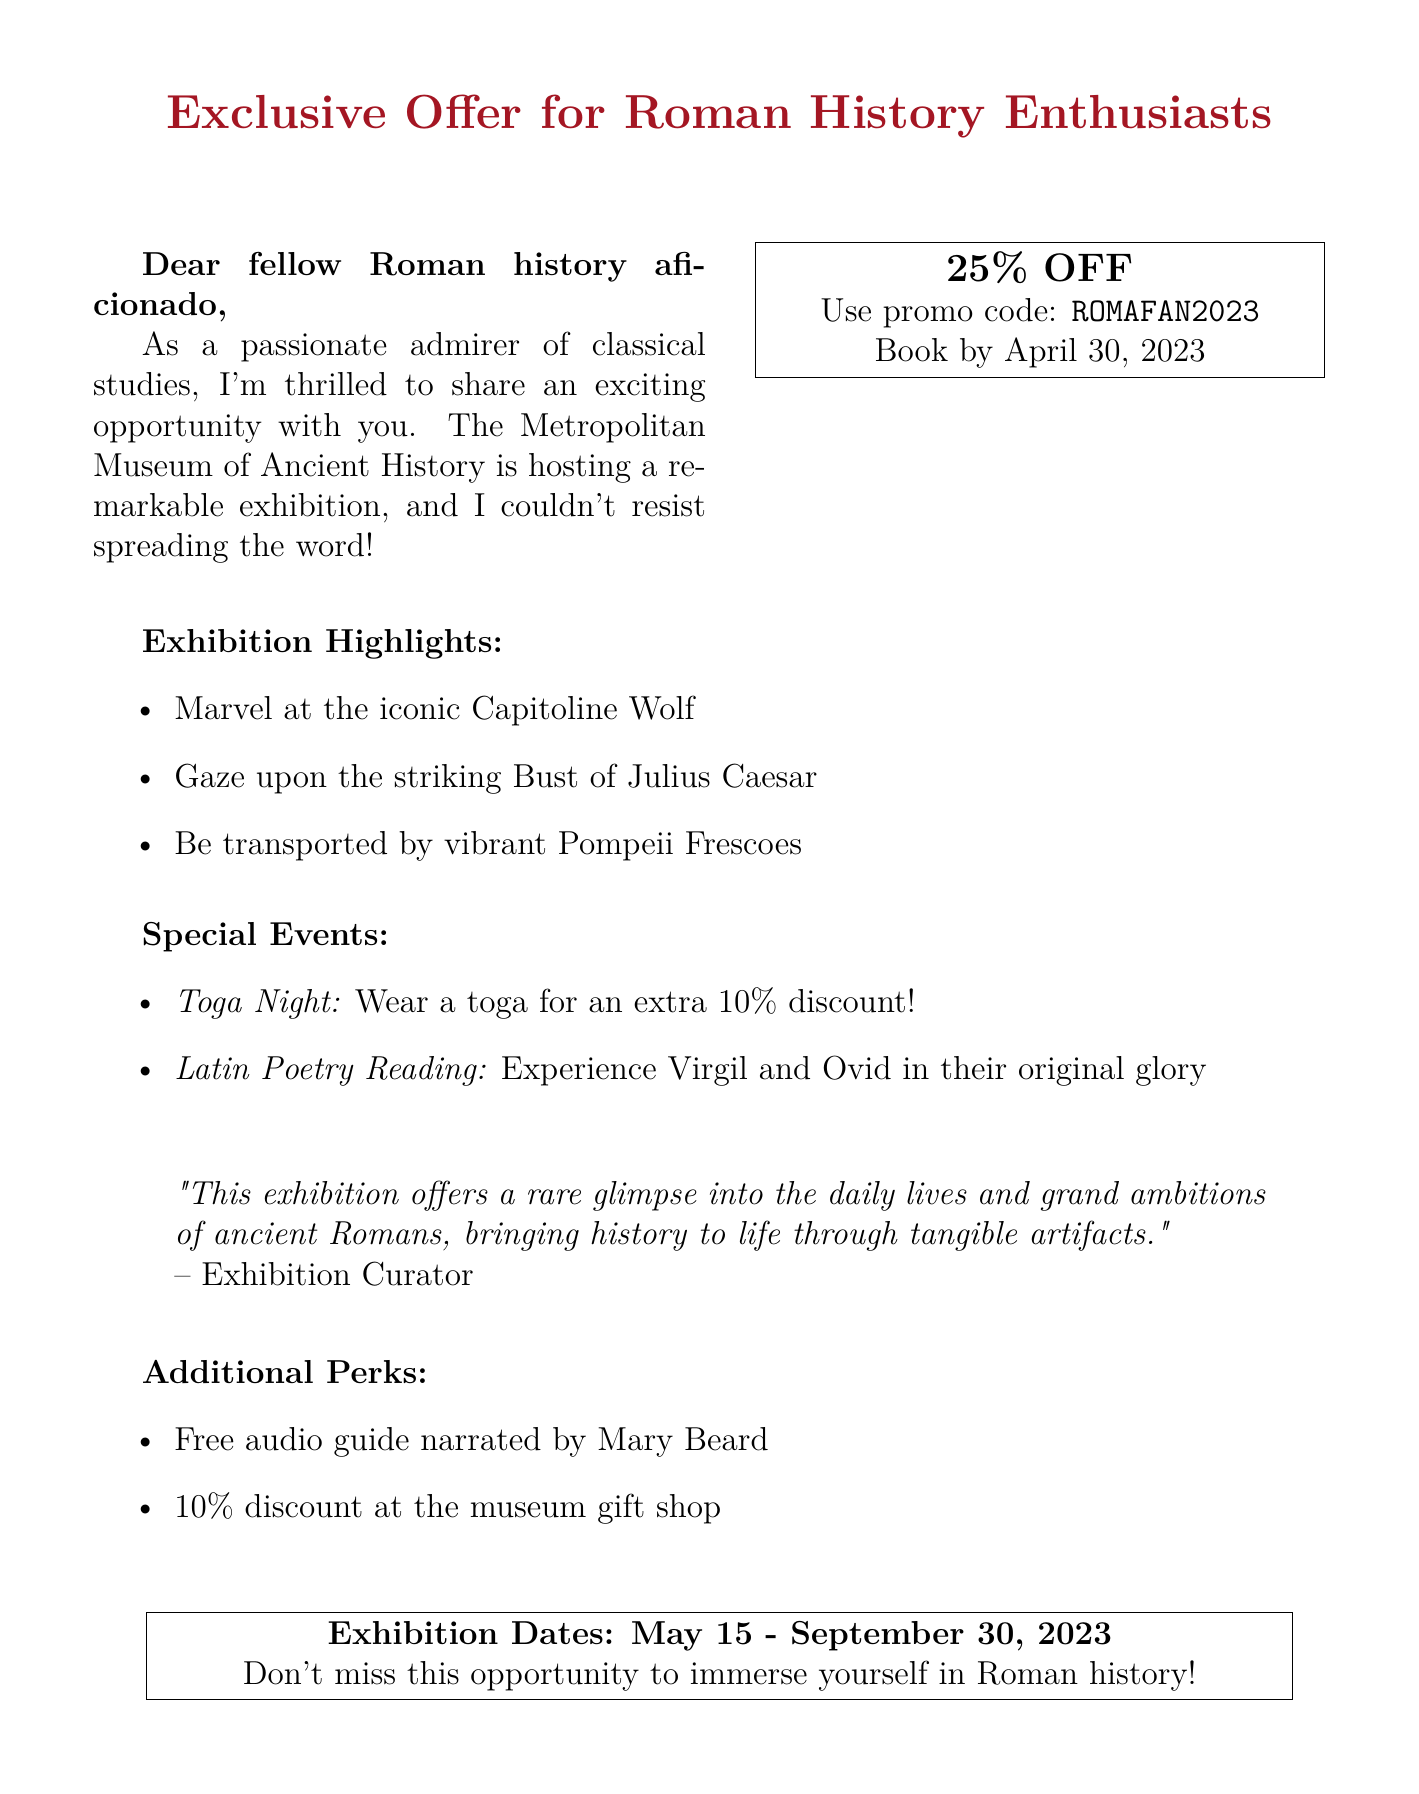What is the title of the exhibition? The title of the exhibition is specified in the document.
Answer: Echoes of Rome: A Journey Through Ancient Roman Artifacts What is the discount percentage offered? The document states the discount percentage available for tickets.
Answer: 25% When is the booking deadline? The document mentions a specific date for booking tickets.
Answer: April 30, 2023 Name one key artifact included in the exhibition. The document lists several key artifacts on display.
Answer: The Capitoline Wolf What is the contact email for ticket inquiries? The contact information for ticket inquiries is provided in the document.
Answer: tickets@metancienthistory.org What additional discount is available on Toga Night? The document describes a special event with an extra discount.
Answer: 10% How long will the exhibition run? The document provides dates for the duration of the exhibition.
Answer: May 15 - September 30, 2023 Who is the narrator of the free audio guide? The document mentions who narrates the audio guide offered at the exhibition.
Answer: Mary Beard 